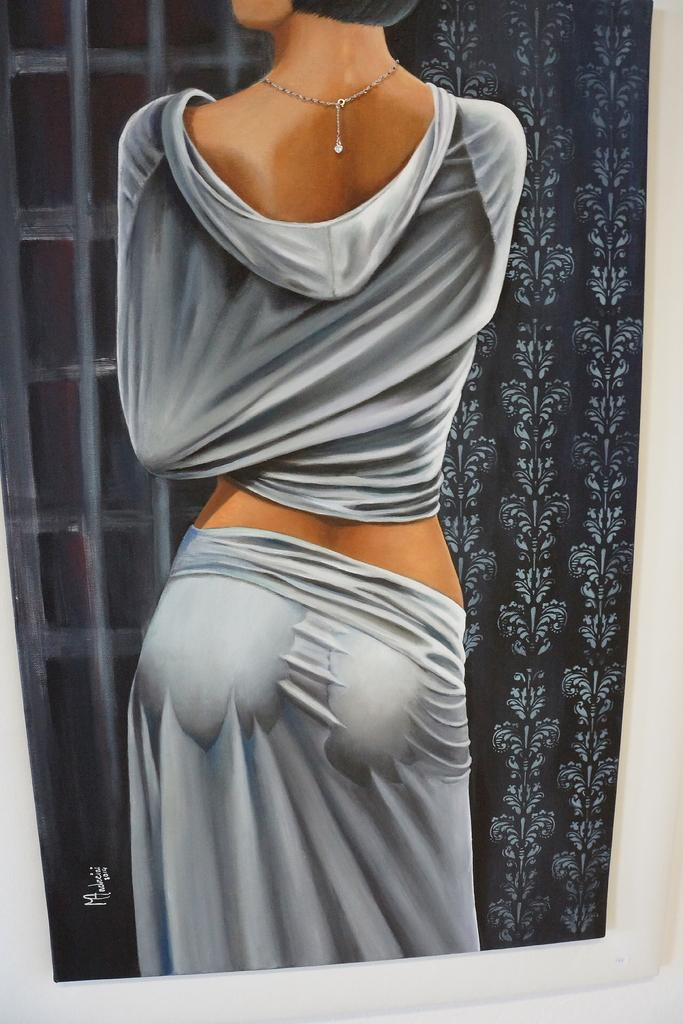What type of artwork is depicted in the image? The image is a painting. Can you describe the subject of the painting? There is a woman in the painting. What is located on the right side of the painting? There is a curtain on the right side of the painting. What type of disease is the woman suffering from in the painting? There is no indication of any disease in the painting; it simply depicts a woman. Can you see any blood on the woman or the curtain in the painting? There is no blood visible in the painting. 